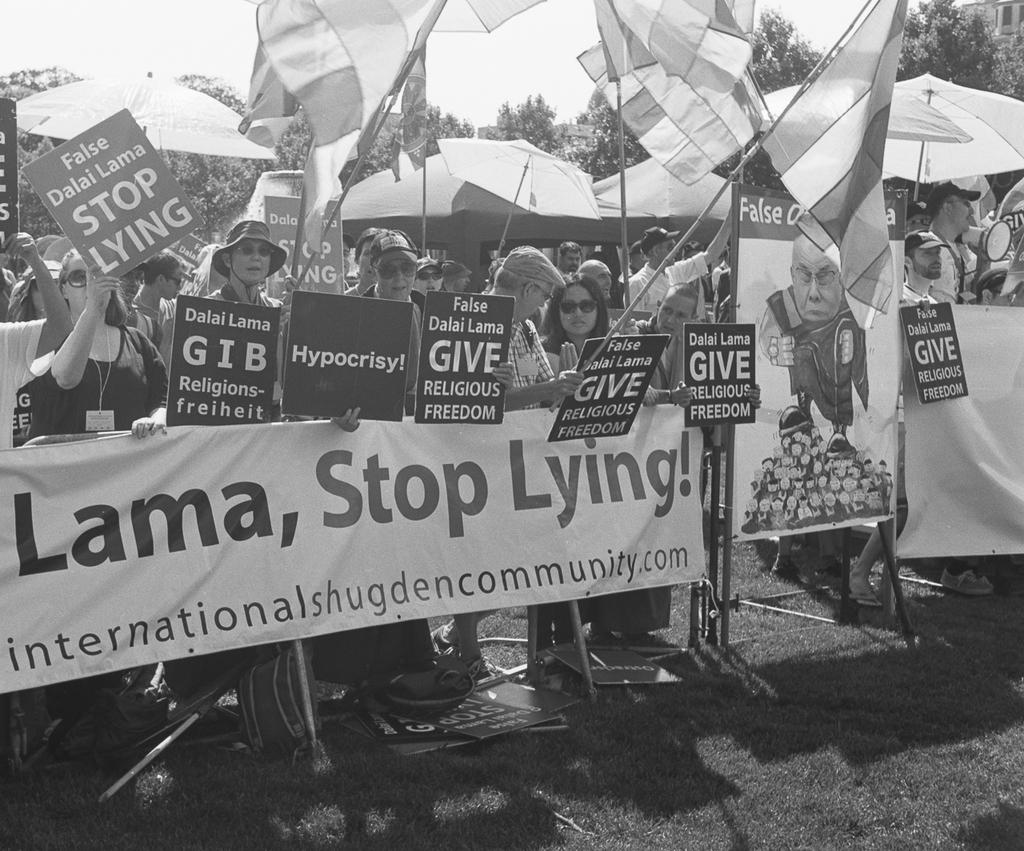What are the people in the image doing? The people in the image are standing and holding boards. What else can be seen in the image besides the people? There are banners and flags in the image. What is visible in the background of the image? There are trees and the sky visible in the background of the image. What type of haircut does the dad have in the image? There is no dad present in the image, and therefore no haircut can be observed. 